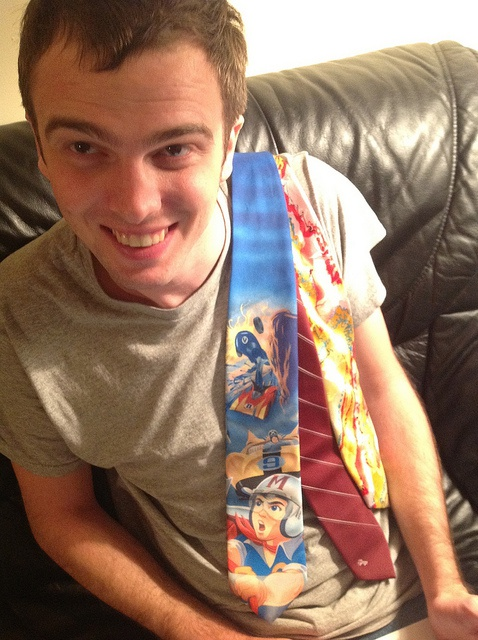Describe the objects in this image and their specific colors. I can see people in tan, maroon, and brown tones, couch in tan, black, and gray tones, tie in tan, lightblue, and gray tones, tie in tan, ivory, khaki, and orange tones, and tie in tan, brown, maroon, and salmon tones in this image. 